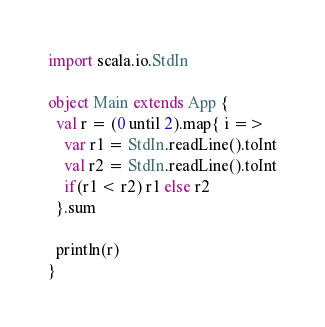<code> <loc_0><loc_0><loc_500><loc_500><_Scala_>import scala.io.StdIn

object Main extends App {
  val r = (0 until 2).map{ i =>
    var r1 = StdIn.readLine().toInt
    val r2 = StdIn.readLine().toInt
    if(r1 < r2) r1 else r2
  }.sum

  println(r)
}
</code> 